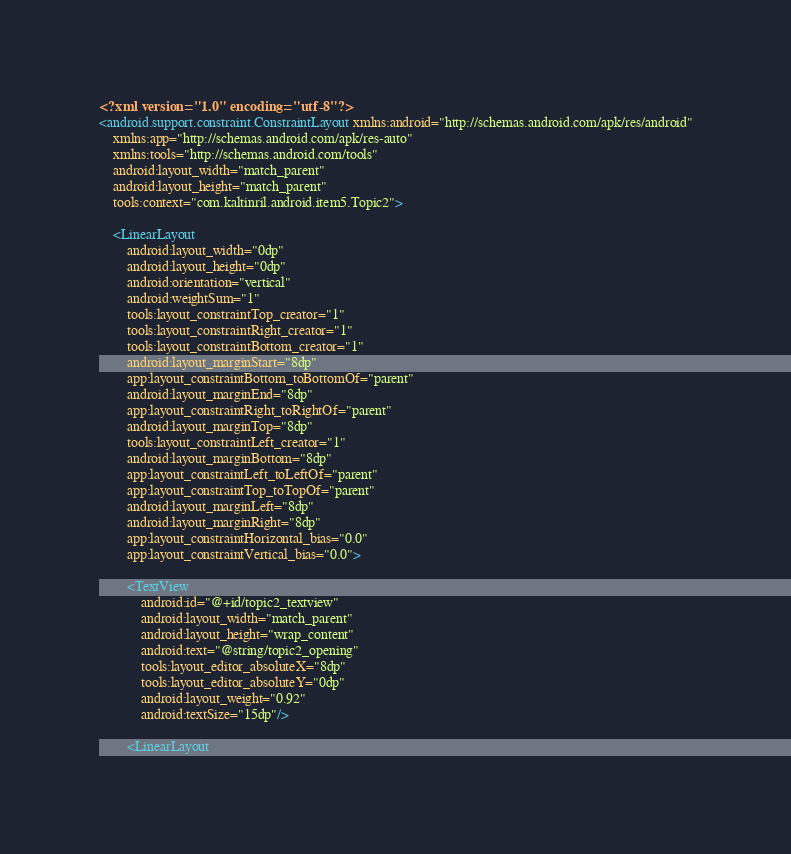Convert code to text. <code><loc_0><loc_0><loc_500><loc_500><_XML_><?xml version="1.0" encoding="utf-8"?>
<android.support.constraint.ConstraintLayout xmlns:android="http://schemas.android.com/apk/res/android"
    xmlns:app="http://schemas.android.com/apk/res-auto"
    xmlns:tools="http://schemas.android.com/tools"
    android:layout_width="match_parent"
    android:layout_height="match_parent"
    tools:context="com.kaltinril.android.item5.Topic2">

    <LinearLayout
        android:layout_width="0dp"
        android:layout_height="0dp"
        android:orientation="vertical"
        android:weightSum="1"
        tools:layout_constraintTop_creator="1"
        tools:layout_constraintRight_creator="1"
        tools:layout_constraintBottom_creator="1"
        android:layout_marginStart="8dp"
        app:layout_constraintBottom_toBottomOf="parent"
        android:layout_marginEnd="8dp"
        app:layout_constraintRight_toRightOf="parent"
        android:layout_marginTop="8dp"
        tools:layout_constraintLeft_creator="1"
        android:layout_marginBottom="8dp"
        app:layout_constraintLeft_toLeftOf="parent"
        app:layout_constraintTop_toTopOf="parent"
        android:layout_marginLeft="8dp"
        android:layout_marginRight="8dp"
        app:layout_constraintHorizontal_bias="0.0"
        app:layout_constraintVertical_bias="0.0">

        <TextView
            android:id="@+id/topic2_textview"
            android:layout_width="match_parent"
            android:layout_height="wrap_content"
            android:text="@string/topic2_opening"
            tools:layout_editor_absoluteX="8dp"
            tools:layout_editor_absoluteY="0dp"
            android:layout_weight="0.92"
            android:textSize="15dp"/>

        <LinearLayout</code> 